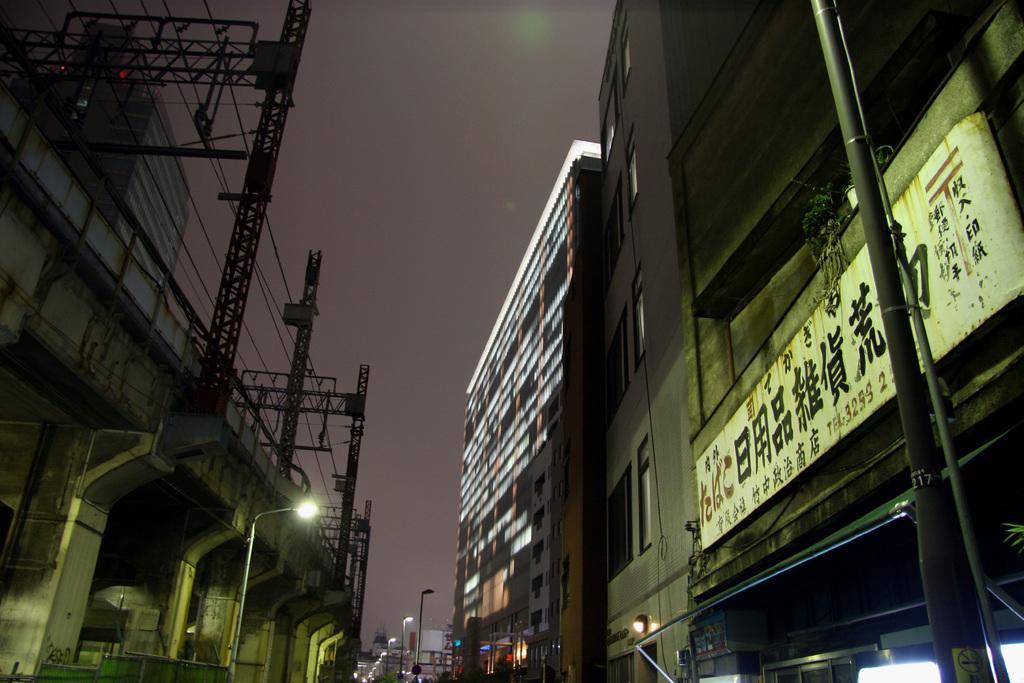Describe this image in one or two sentences. In the center of the image we can see the sky,buildings,poles,lights,banners and few other objects. 